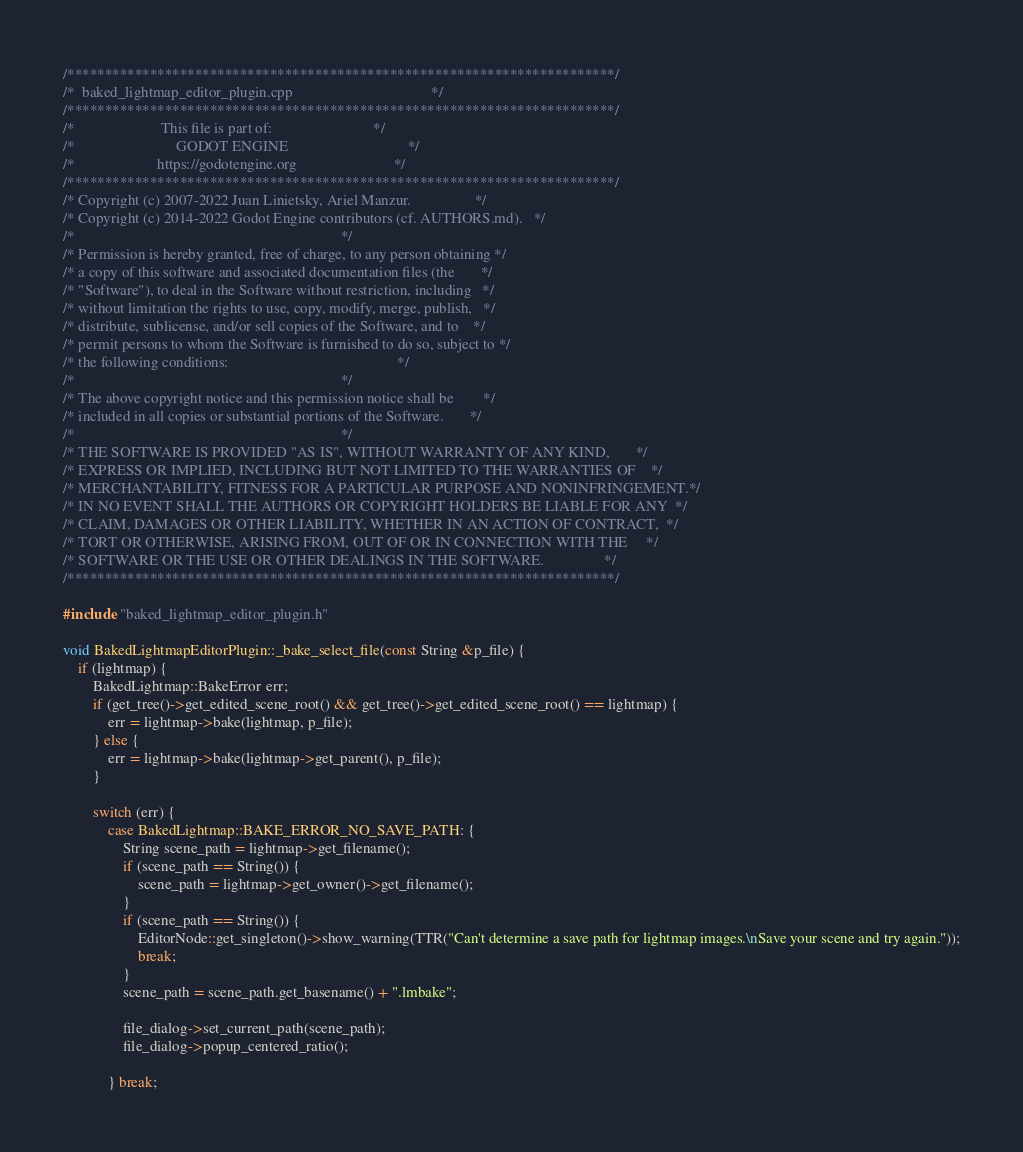<code> <loc_0><loc_0><loc_500><loc_500><_C++_>/*************************************************************************/
/*  baked_lightmap_editor_plugin.cpp                                     */
/*************************************************************************/
/*                       This file is part of:                           */
/*                           GODOT ENGINE                                */
/*                      https://godotengine.org                          */
/*************************************************************************/
/* Copyright (c) 2007-2022 Juan Linietsky, Ariel Manzur.                 */
/* Copyright (c) 2014-2022 Godot Engine contributors (cf. AUTHORS.md).   */
/*                                                                       */
/* Permission is hereby granted, free of charge, to any person obtaining */
/* a copy of this software and associated documentation files (the       */
/* "Software"), to deal in the Software without restriction, including   */
/* without limitation the rights to use, copy, modify, merge, publish,   */
/* distribute, sublicense, and/or sell copies of the Software, and to    */
/* permit persons to whom the Software is furnished to do so, subject to */
/* the following conditions:                                             */
/*                                                                       */
/* The above copyright notice and this permission notice shall be        */
/* included in all copies or substantial portions of the Software.       */
/*                                                                       */
/* THE SOFTWARE IS PROVIDED "AS IS", WITHOUT WARRANTY OF ANY KIND,       */
/* EXPRESS OR IMPLIED, INCLUDING BUT NOT LIMITED TO THE WARRANTIES OF    */
/* MERCHANTABILITY, FITNESS FOR A PARTICULAR PURPOSE AND NONINFRINGEMENT.*/
/* IN NO EVENT SHALL THE AUTHORS OR COPYRIGHT HOLDERS BE LIABLE FOR ANY  */
/* CLAIM, DAMAGES OR OTHER LIABILITY, WHETHER IN AN ACTION OF CONTRACT,  */
/* TORT OR OTHERWISE, ARISING FROM, OUT OF OR IN CONNECTION WITH THE     */
/* SOFTWARE OR THE USE OR OTHER DEALINGS IN THE SOFTWARE.                */
/*************************************************************************/

#include "baked_lightmap_editor_plugin.h"

void BakedLightmapEditorPlugin::_bake_select_file(const String &p_file) {
	if (lightmap) {
		BakedLightmap::BakeError err;
		if (get_tree()->get_edited_scene_root() && get_tree()->get_edited_scene_root() == lightmap) {
			err = lightmap->bake(lightmap, p_file);
		} else {
			err = lightmap->bake(lightmap->get_parent(), p_file);
		}

		switch (err) {
			case BakedLightmap::BAKE_ERROR_NO_SAVE_PATH: {
				String scene_path = lightmap->get_filename();
				if (scene_path == String()) {
					scene_path = lightmap->get_owner()->get_filename();
				}
				if (scene_path == String()) {
					EditorNode::get_singleton()->show_warning(TTR("Can't determine a save path for lightmap images.\nSave your scene and try again."));
					break;
				}
				scene_path = scene_path.get_basename() + ".lmbake";

				file_dialog->set_current_path(scene_path);
				file_dialog->popup_centered_ratio();

			} break;</code> 